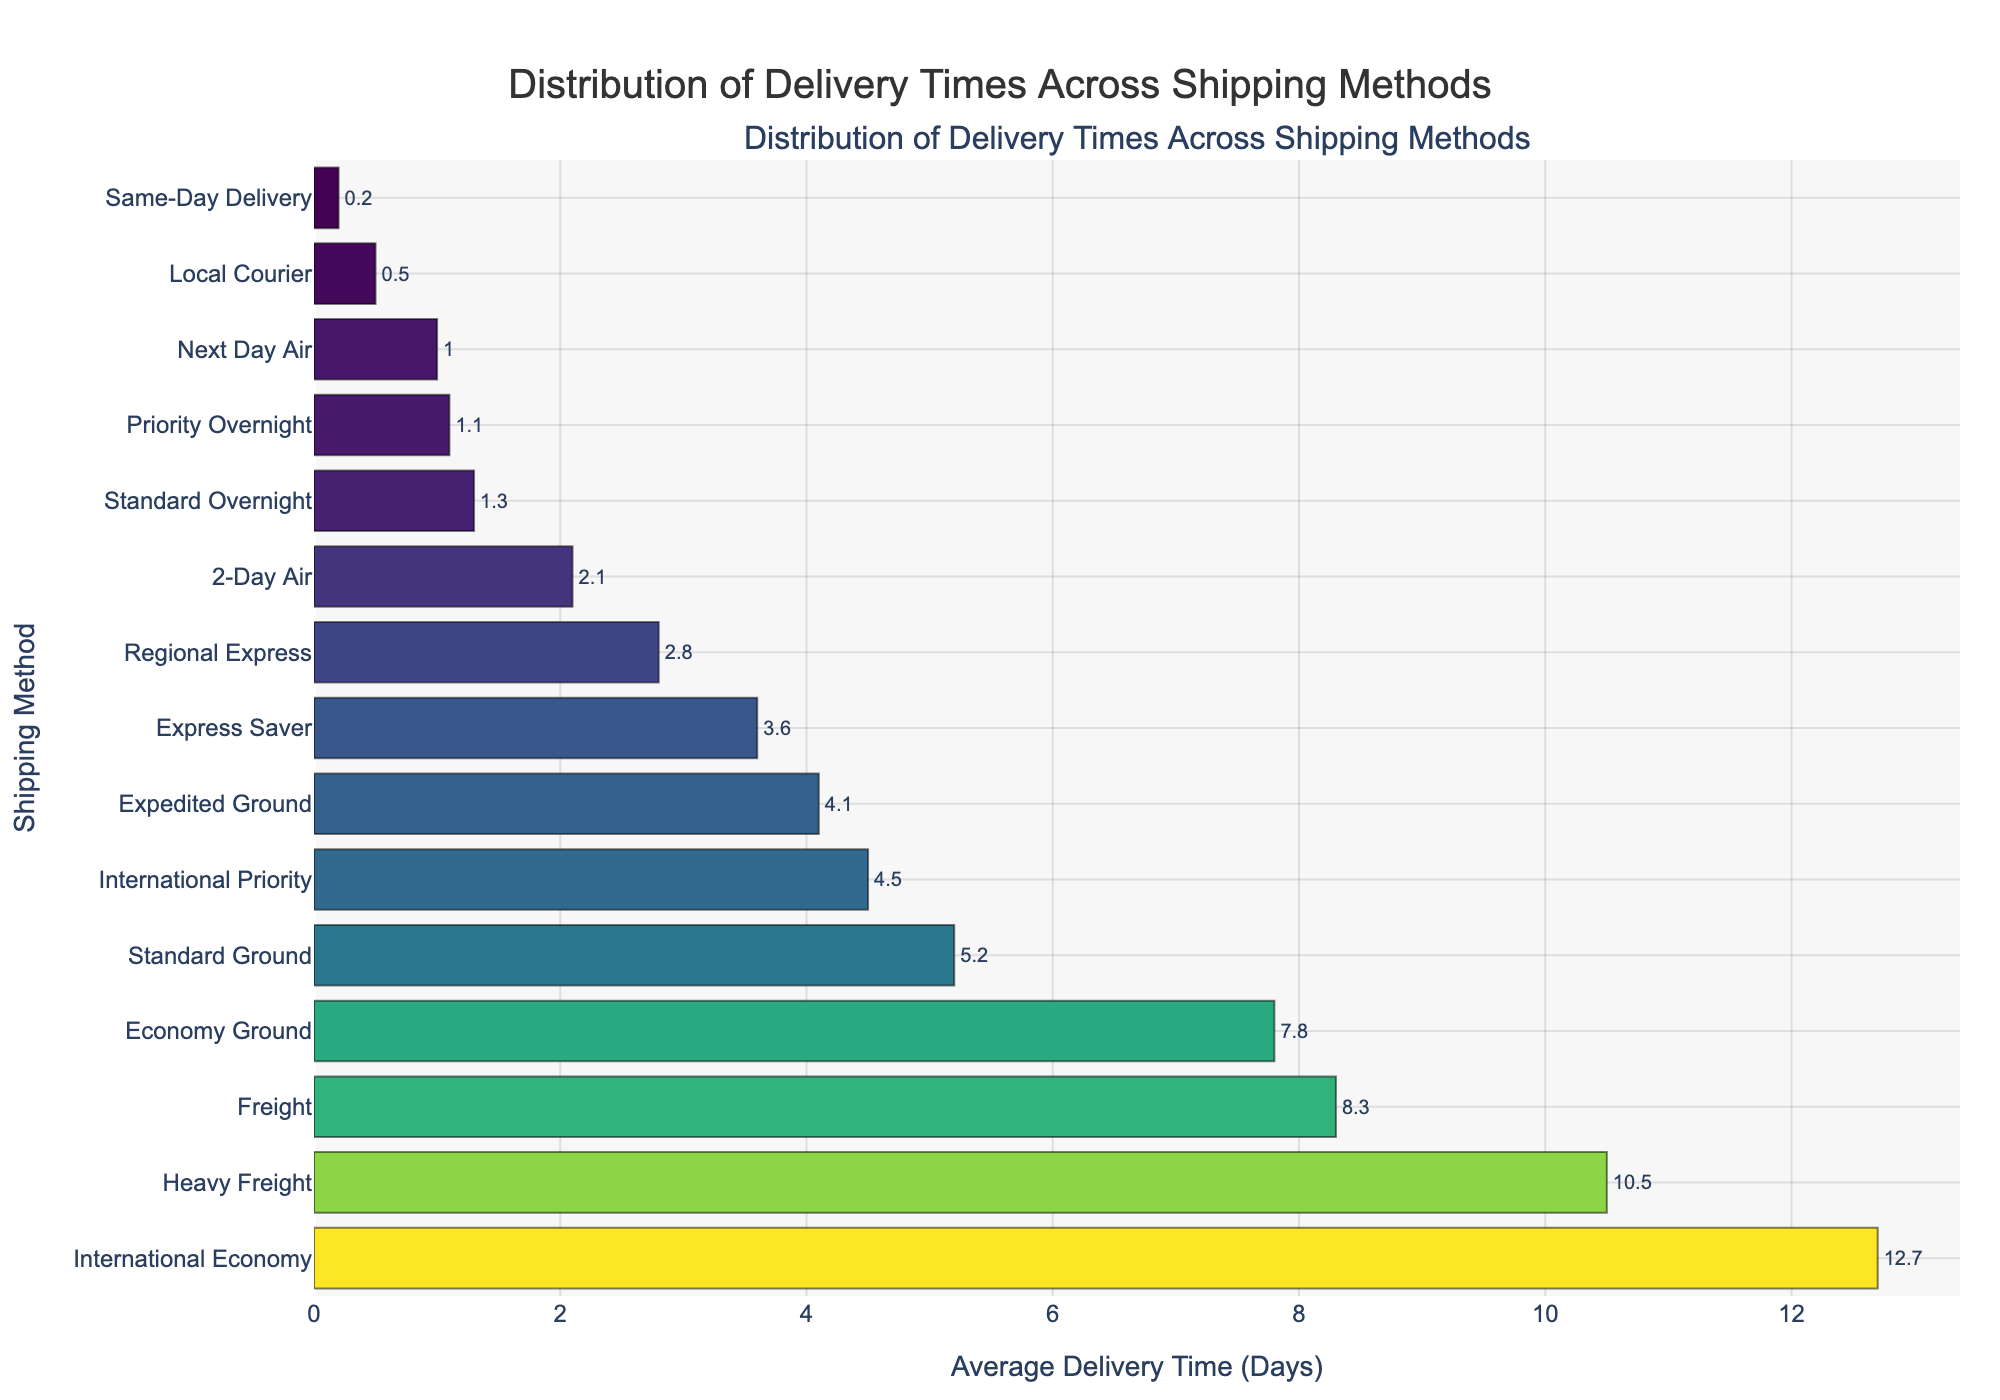Which shipping method has the longest average delivery time? The figure shows the bars representing average delivery times for different shipping methods, and the longest bar represents the method with the longest time. The longest bar corresponds to International Economy.
Answer: International Economy What is the difference in average delivery time between Standard Ground and Expedited Ground? The average delivery time for Standard Ground is 5.2 days and for Expedited Ground is 4.1 days. The difference is 5.2 - 4.1 = 1.1 days.
Answer: 1.1 days Which shipping method has the shortest average delivery time? The figure shows the bars in descending order of delivery times. The shortest bar represents Same-Day Delivery with an average time of 0.2 days.
Answer: Same-Day Delivery How many shipping methods have an average delivery time greater than 5 days? From the chart, identify the methods with bars exceeding the 5-day mark. These methods are Standard Ground, International Economy, Freight, Economy Ground, and Heavy Freight, totaling 5 methods.
Answer: 5 methods Which methods have an average delivery time between 2 and 3 days? From the chart, locate the shipping methods whose bars fall within the 2 to 3 days range. These methods are 2-Day Air (2.1 days) and Regional Express (2.8 days).
Answer: 2-Day Air, Regional Express How does the average delivery time of International Priority compare to Express Saver? The chart indicates that International Priority has an average delivery time of 4.5 days, while Express Saver has an average of 3.6 days. International Priority is slower.
Answer: International Priority is slower What is the combined average delivery time for the fastest three shipping methods? The figure shows the fastest three methods: Same-Day Delivery (0.2 days), Local Courier (0.5 days), and Next Day Air (1.0 days). Sum them up: 0.2 + 0.5 + 1.0 = 1.7 days.
Answer: 1.7 days Which shipping method has an average delivery time closest to 5 days? The chart shows Standard Ground with an average delivery time of 5.2 days, which is closest to 5 days.
Answer: Standard Ground How much faster is 2-Day Air compared to Economy Ground? 2-Day Air has an average delivery time of 2.1 days, and Economy Ground is 7.8 days. The difference is 7.8 - 2.1 = 5.7 days.
Answer: 5.7 days 